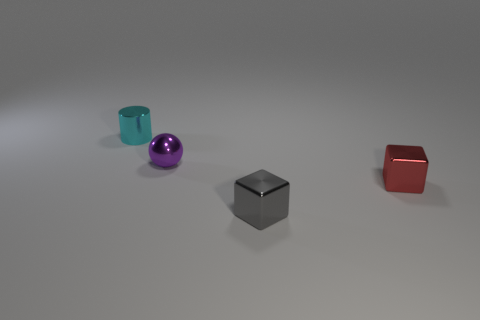Add 4 small things. How many objects exist? 8 Subtract all spheres. How many objects are left? 3 Subtract all big purple shiny cylinders. Subtract all small gray metallic cubes. How many objects are left? 3 Add 4 red metallic objects. How many red metallic objects are left? 5 Add 1 purple metal spheres. How many purple metal spheres exist? 2 Subtract 0 green cylinders. How many objects are left? 4 